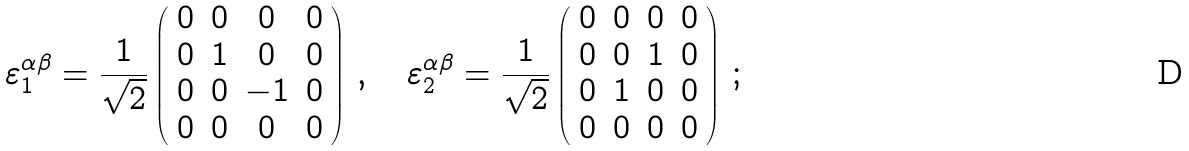Convert formula to latex. <formula><loc_0><loc_0><loc_500><loc_500>\varepsilon ^ { \alpha \beta } _ { 1 } = \frac { 1 } { \sqrt { 2 } } \left ( \begin{array} { c c c c } 0 & 0 & 0 & 0 \\ 0 & 1 & 0 & 0 \\ 0 & 0 & - 1 & 0 \\ 0 & 0 & 0 & 0 \end{array} \right ) \, , \quad \varepsilon ^ { \alpha \beta } _ { 2 } = \frac { 1 } { \sqrt { 2 } } \left ( \begin{array} { c c c c } 0 & 0 & 0 & 0 \\ 0 & 0 & 1 & 0 \\ 0 & 1 & 0 & 0 \\ 0 & 0 & 0 & 0 \end{array} \right ) \, ;</formula> 